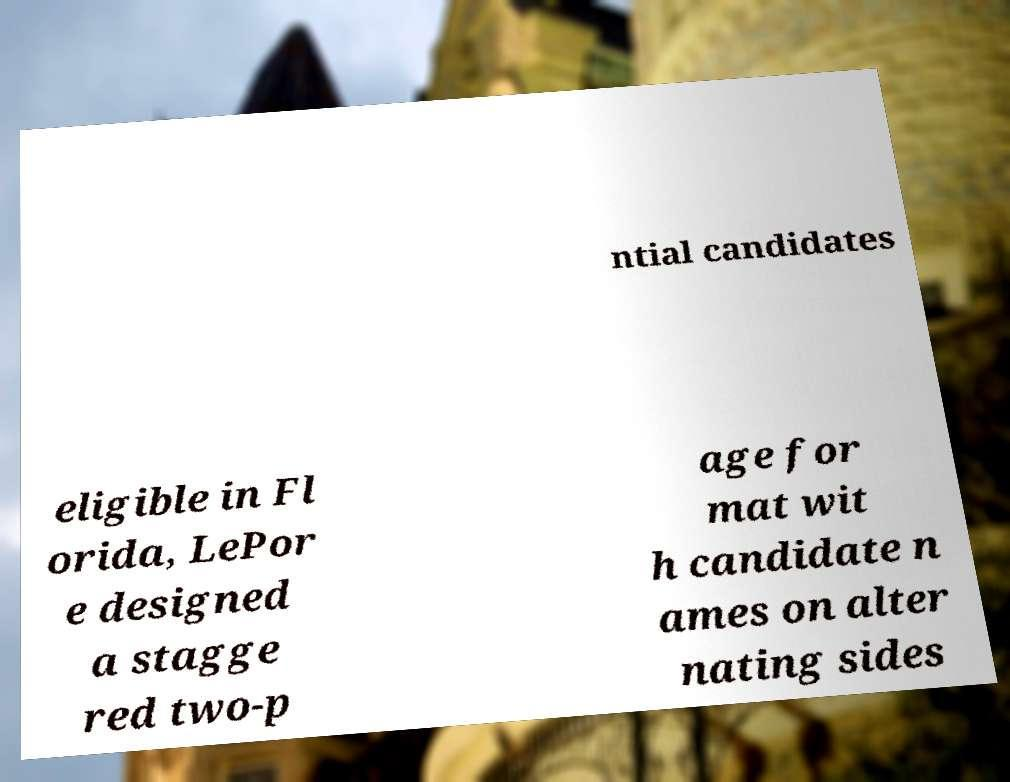There's text embedded in this image that I need extracted. Can you transcribe it verbatim? ntial candidates eligible in Fl orida, LePor e designed a stagge red two-p age for mat wit h candidate n ames on alter nating sides 